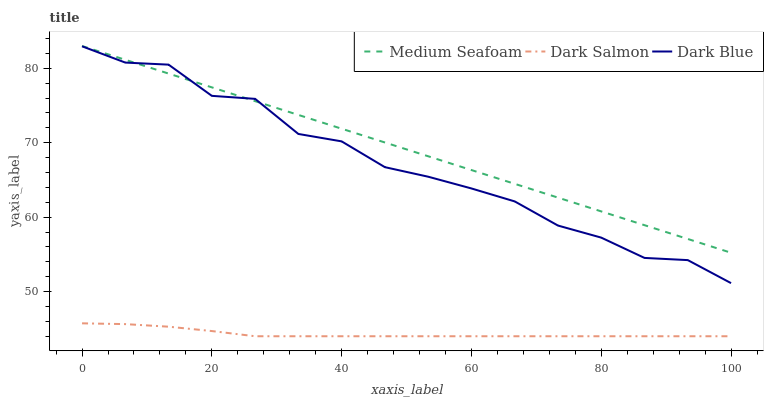Does Dark Salmon have the minimum area under the curve?
Answer yes or no. Yes. Does Medium Seafoam have the maximum area under the curve?
Answer yes or no. Yes. Does Medium Seafoam have the minimum area under the curve?
Answer yes or no. No. Does Dark Salmon have the maximum area under the curve?
Answer yes or no. No. Is Medium Seafoam the smoothest?
Answer yes or no. Yes. Is Dark Blue the roughest?
Answer yes or no. Yes. Is Dark Salmon the smoothest?
Answer yes or no. No. Is Dark Salmon the roughest?
Answer yes or no. No. Does Medium Seafoam have the lowest value?
Answer yes or no. No. Does Medium Seafoam have the highest value?
Answer yes or no. Yes. Does Dark Salmon have the highest value?
Answer yes or no. No. Is Dark Salmon less than Medium Seafoam?
Answer yes or no. Yes. Is Medium Seafoam greater than Dark Salmon?
Answer yes or no. Yes. Does Dark Blue intersect Medium Seafoam?
Answer yes or no. Yes. Is Dark Blue less than Medium Seafoam?
Answer yes or no. No. Is Dark Blue greater than Medium Seafoam?
Answer yes or no. No. Does Dark Salmon intersect Medium Seafoam?
Answer yes or no. No. 